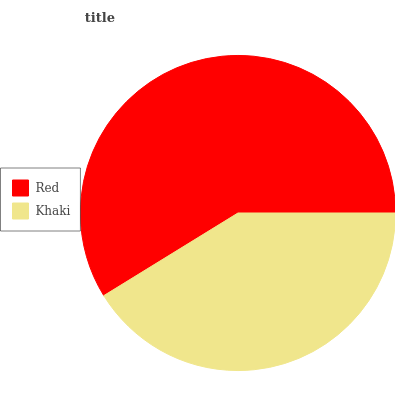Is Khaki the minimum?
Answer yes or no. Yes. Is Red the maximum?
Answer yes or no. Yes. Is Khaki the maximum?
Answer yes or no. No. Is Red greater than Khaki?
Answer yes or no. Yes. Is Khaki less than Red?
Answer yes or no. Yes. Is Khaki greater than Red?
Answer yes or no. No. Is Red less than Khaki?
Answer yes or no. No. Is Red the high median?
Answer yes or no. Yes. Is Khaki the low median?
Answer yes or no. Yes. Is Khaki the high median?
Answer yes or no. No. Is Red the low median?
Answer yes or no. No. 